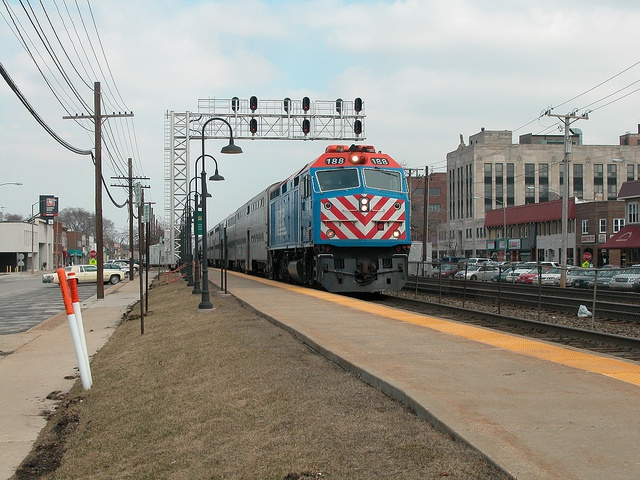Describe the objects in this image and their specific colors. I can see train in lightblue, black, gray, darkgray, and blue tones, car in lightblue, gray, black, darkgray, and teal tones, car in lightblue, gray, lightgray, beige, and darkgray tones, car in lightblue, gray, black, darkgray, and purple tones, and car in lightblue, gray, black, darkgray, and lightgray tones in this image. 